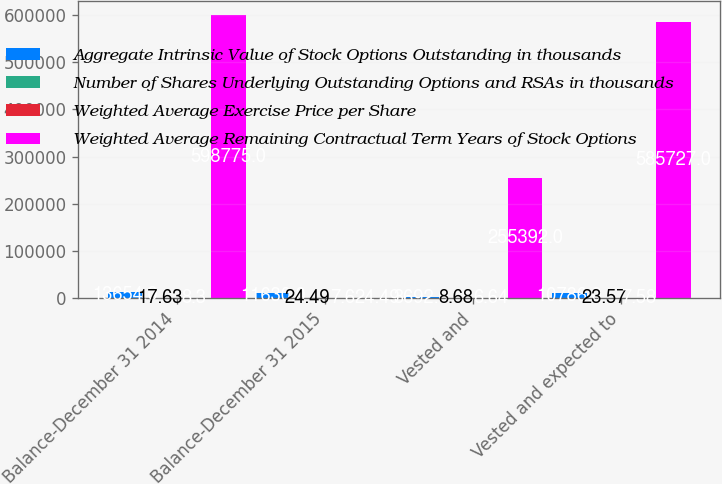Convert chart. <chart><loc_0><loc_0><loc_500><loc_500><stacked_bar_chart><ecel><fcel>Balance-December 31 2014<fcel>Balance-December 31 2015<fcel>Vested and<fcel>Vested and expected to<nl><fcel>Aggregate Intrinsic Value of Stock Options Outstanding in thousands<fcel>13654<fcel>11630<fcel>3692<fcel>10786<nl><fcel>Number of Shares Underlying Outstanding Options and RSAs in thousands<fcel>17.63<fcel>24.49<fcel>8.68<fcel>23.57<nl><fcel>Weighted Average Exercise Price per Share<fcel>8.3<fcel>7.6<fcel>6.64<fcel>7.58<nl><fcel>Weighted Average Remaining Contractual Term Years of Stock Options<fcel>598775<fcel>24.49<fcel>255392<fcel>585727<nl></chart> 